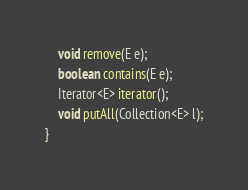<code> <loc_0><loc_0><loc_500><loc_500><_Java_>    void remove(E e);
    boolean contains(E e);
    Iterator<E> iterator();
    void putAll(Collection<E> l);
}
</code> 